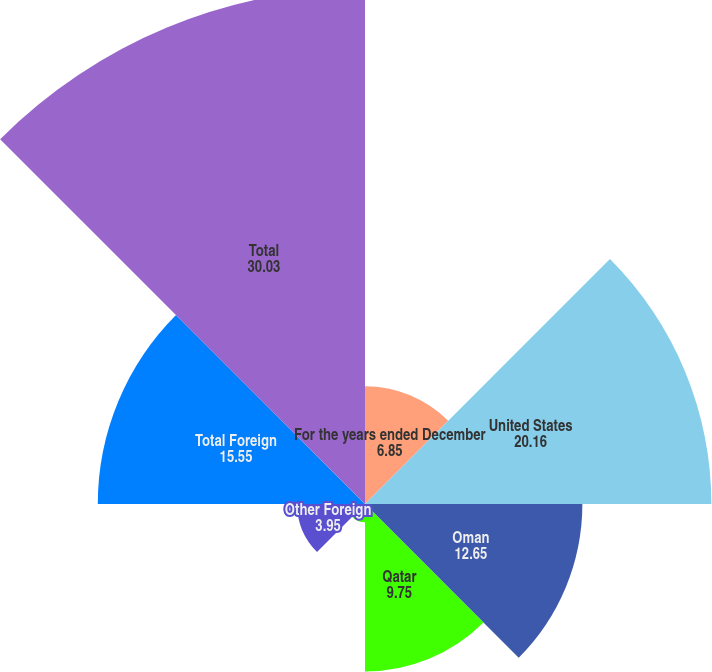<chart> <loc_0><loc_0><loc_500><loc_500><pie_chart><fcel>For the years ended December<fcel>United States<fcel>Oman<fcel>Qatar<fcel>Colombia<fcel>Other Foreign<fcel>Total Foreign<fcel>Total<nl><fcel>6.85%<fcel>20.16%<fcel>12.65%<fcel>9.75%<fcel>1.06%<fcel>3.95%<fcel>15.55%<fcel>30.03%<nl></chart> 